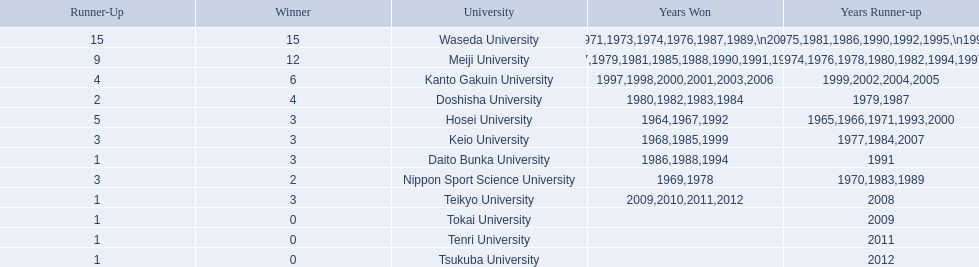What university were there in the all-japan university rugby championship? Waseda University, Meiji University, Kanto Gakuin University, Doshisha University, Hosei University, Keio University, Daito Bunka University, Nippon Sport Science University, Teikyo University, Tokai University, Tenri University, Tsukuba University. Of these who had more than 12 wins? Waseda University. 